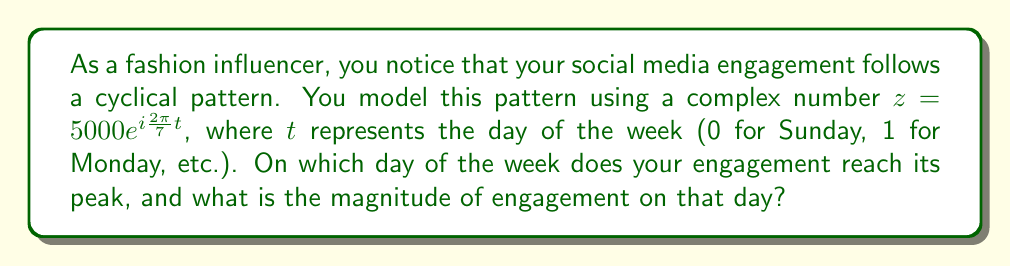Show me your answer to this math problem. Let's approach this step-by-step:

1) The complex number $z = 5000e^{i\frac{2\pi}{7}t}$ represents the engagement pattern.

2) The magnitude of this complex number is constant at 5000, as $|e^{i\theta}| = 1$ for any real $\theta$.

3) The angle of the complex number changes with $t$:
   $\theta = \frac{2\pi}{7}t$

4) The engagement reaches its peak when the complex number is purely real and positive, i.e., when $\theta = 0$ (or any multiple of $2\pi$).

5) Solving for $t$:
   $\frac{2\pi}{7}t = 0$
   $t = 0$

6) $t = 0$ corresponds to Sunday in our model.

7) The magnitude of engagement is constant at 5000 for all days.
Answer: Sunday, 5000 